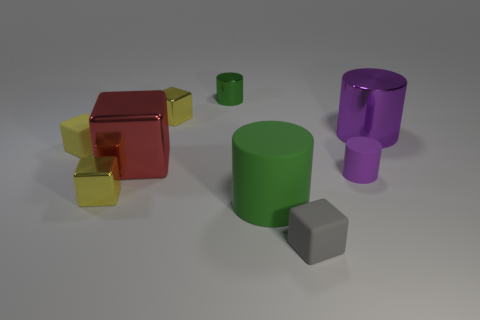What is the material of the other cylinder that is the same color as the large rubber cylinder?
Your answer should be compact. Metal. Are there any red metal blocks that have the same size as the purple matte thing?
Offer a very short reply. No. How many small metal objects are there?
Keep it short and to the point. 3. What number of big red blocks are in front of the red thing?
Make the answer very short. 0. Is the material of the small gray thing the same as the big red block?
Offer a terse response. No. How many small things are both in front of the green matte cylinder and right of the small gray matte block?
Ensure brevity in your answer.  0. What number of other objects are the same color as the tiny matte cylinder?
Keep it short and to the point. 1. How many purple things are either big cylinders or big rubber objects?
Ensure brevity in your answer.  1. How big is the red metallic block?
Your response must be concise. Large. How many rubber things are either large green things or big brown things?
Your answer should be compact. 1. 